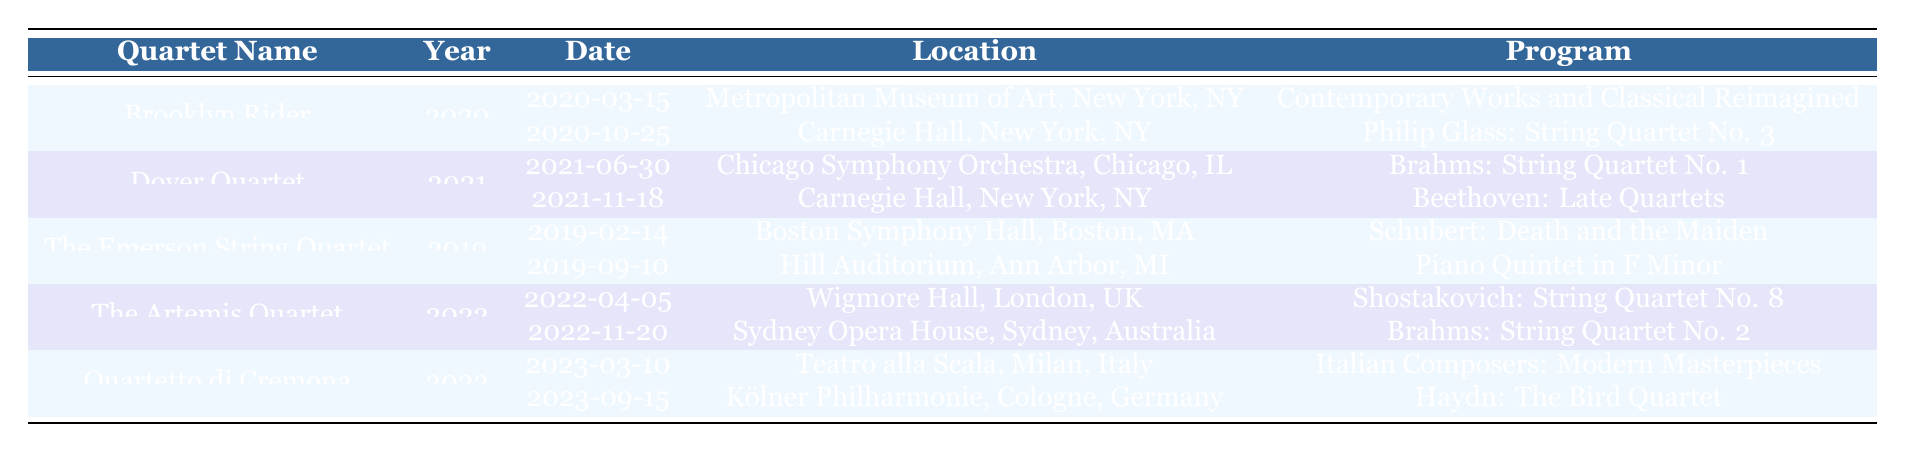What is the total number of performances listed in the table? The table lists performances for five string quartets. Brooklyn Rider has 2 performances, Dover Quartet has 2, The Emerson String Quartet has 2, The Artemis Quartet has 2, and Quartetto di Cremona has 2. Adding them gives 2 + 2 + 2 + 2 + 2 = 10 performances in total.
Answer: 10 Which quartet performed at Carnegie Hall in 2021? The table shows that Dover Quartet performed at Carnegie Hall on November 18, 2021.
Answer: Dover Quartet What program did Brooklyn Rider perform at the Metropolitan Museum of Art? According to the table, Brooklyn Rider's performance on March 15, 2020, at the Metropolitan Museum of Art featured the program "Contemporary Works and Classical Reimagined."
Answer: Contemporary Works and Classical Reimagined Did any quartet perform with a guest performer in 2019? By examining the table, it shows that The Emerson String Quartet had a performance with guest performer Yefim Bronfman on September 10, 2019.
Answer: Yes How many different locations did the Quartetto di Cremona perform at? The table lists two performances for Quartetto di Cremona in 2023, one at Teatro alla Scala and another at Kölner Philharmonie, which means they performed at 2 different locations.
Answer: 2 What is the earliest performance date listed in the table? The table indicates that the earliest performance date is February 14, 2019, for The Emerson String Quartet at Boston Symphony Hall.
Answer: 2019-02-14 Which program featured a guest performer, and who was it for the performance at Sydney Opera House? The performance on November 20, 2022, by The Artemis Quartet at Sydney Opera House featured the program "Brahms: String Quartet No. 2" with guest performer Alisa Weilerstein.
Answer: Brahms: String Quartet No. 2, Alisa Weilerstein Calculate the total number of performances by year for 2020. The table shows that Brooklyn Rider had 2 performances in 2020. Thus, the total number of performances for that year is 2.
Answer: 2 What was the most recent performance date in the table? By inspecting the table, the most recent performance date is September 15, 2023, by Quartetto di Cremona at Kölner Philharmonie.
Answer: 2023-09-15 Which quartet's performances included a work by Brahms? The performances of The Artemis Quartet included Brahms: String Quartet No. 2 on November 20, 2022, and Dover Quartet performed Brahms: String Quartet No. 1 on June 30, 2021.
Answer: The Artemis Quartet and Dover Quartet How many performances did The Emerson String Quartet have, and what were their programs? The Emerson String Quartet had 2 performances in total: "Schubert: Death and the Maiden" on February 14, 2019, and "Piano Quintet in F Minor" on September 10, 2019.
Answer: 2 performances, Schubert: Death and the Maiden, Piano Quintet in F Minor 